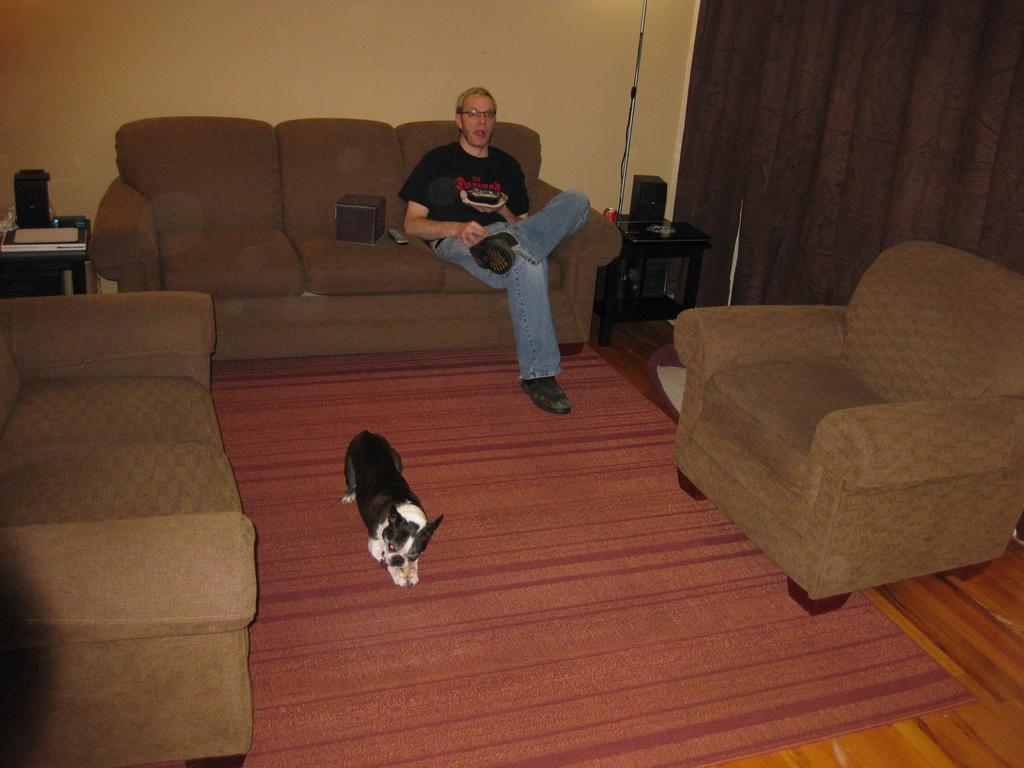Can you describe this image briefly? This is a picture of a room where we have the sofas and a dog in between the sofas on the floor mat and beside the sofa there is a desk on which some things are placed and on the sofa there is a man who is wearing a black shirt and blue jeans and a remote on it and beside them there is a desk where a speaker and a coke placed on it. 